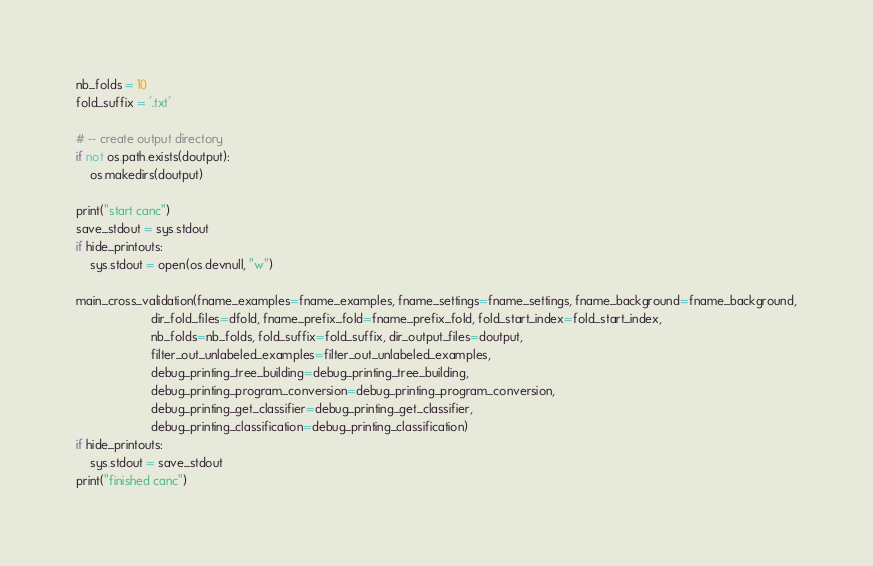Convert code to text. <code><loc_0><loc_0><loc_500><loc_500><_Python_>nb_folds = 10
fold_suffix = '.txt'

# -- create output directory
if not os.path.exists(doutput):
    os.makedirs(doutput)

print("start canc")
save_stdout = sys.stdout
if hide_printouts:
    sys.stdout = open(os.devnull, "w")

main_cross_validation(fname_examples=fname_examples, fname_settings=fname_settings, fname_background=fname_background,
                      dir_fold_files=dfold, fname_prefix_fold=fname_prefix_fold, fold_start_index=fold_start_index,
                      nb_folds=nb_folds, fold_suffix=fold_suffix, dir_output_files=doutput,
                      filter_out_unlabeled_examples=filter_out_unlabeled_examples,
                      debug_printing_tree_building=debug_printing_tree_building,
                      debug_printing_program_conversion=debug_printing_program_conversion,
                      debug_printing_get_classifier=debug_printing_get_classifier,
                      debug_printing_classification=debug_printing_classification)
if hide_printouts:
    sys.stdout = save_stdout
print("finished canc")
</code> 